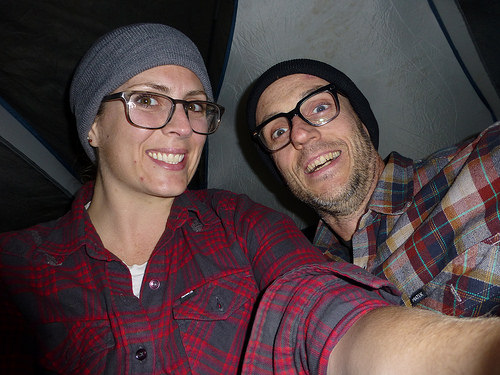<image>
Can you confirm if the girl is behind the boy? No. The girl is not behind the boy. From this viewpoint, the girl appears to be positioned elsewhere in the scene. 